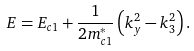<formula> <loc_0><loc_0><loc_500><loc_500>E = E _ { c 1 } + \frac { 1 } { 2 m ^ { * } _ { c 1 } } \left ( k ^ { 2 } _ { y } - k ^ { 2 } _ { 3 } \right ) .</formula> 